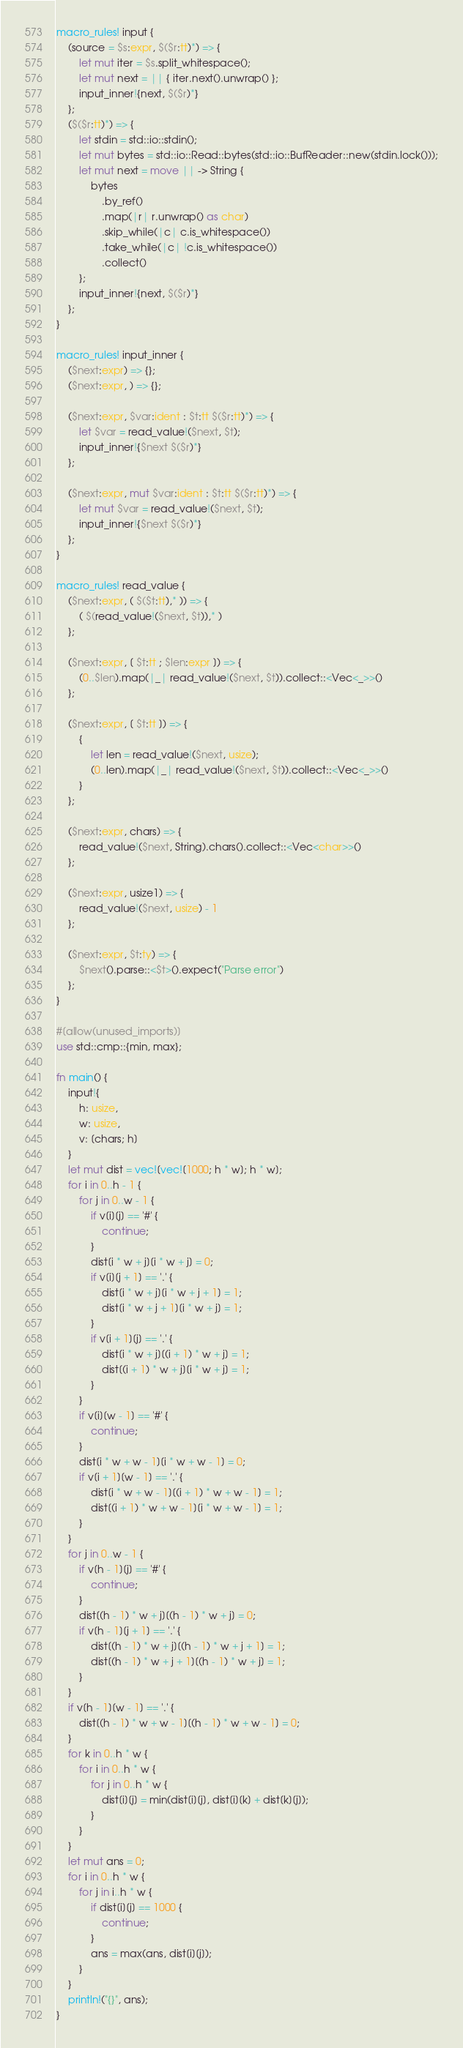Convert code to text. <code><loc_0><loc_0><loc_500><loc_500><_Rust_>macro_rules! input {
    (source = $s:expr, $($r:tt)*) => {
        let mut iter = $s.split_whitespace();
        let mut next = || { iter.next().unwrap() };
        input_inner!{next, $($r)*}
    };
    ($($r:tt)*) => {
        let stdin = std::io::stdin();
        let mut bytes = std::io::Read::bytes(std::io::BufReader::new(stdin.lock()));
        let mut next = move || -> String {
            bytes
                .by_ref()
                .map(|r| r.unwrap() as char)
                .skip_while(|c| c.is_whitespace())
                .take_while(|c| !c.is_whitespace())
                .collect()
        };
        input_inner!{next, $($r)*}
    };
}

macro_rules! input_inner {
    ($next:expr) => {};
    ($next:expr, ) => {};

    ($next:expr, $var:ident : $t:tt $($r:tt)*) => {
        let $var = read_value!($next, $t);
        input_inner!{$next $($r)*}
    };

    ($next:expr, mut $var:ident : $t:tt $($r:tt)*) => {
        let mut $var = read_value!($next, $t);
        input_inner!{$next $($r)*}
    };
}

macro_rules! read_value {
    ($next:expr, ( $($t:tt),* )) => {
        ( $(read_value!($next, $t)),* )
    };

    ($next:expr, [ $t:tt ; $len:expr ]) => {
        (0..$len).map(|_| read_value!($next, $t)).collect::<Vec<_>>()
    };

    ($next:expr, [ $t:tt ]) => {
        {
            let len = read_value!($next, usize);
            (0..len).map(|_| read_value!($next, $t)).collect::<Vec<_>>()
        }
    };

    ($next:expr, chars) => {
        read_value!($next, String).chars().collect::<Vec<char>>()
    };

    ($next:expr, usize1) => {
        read_value!($next, usize) - 1
    };

    ($next:expr, $t:ty) => {
        $next().parse::<$t>().expect("Parse error")
    };
}

#[allow(unused_imports)]
use std::cmp::{min, max};

fn main() {
    input!{
        h: usize,
        w: usize,
        v: [chars; h]
    }
    let mut dist = vec![vec![1000; h * w]; h * w];
    for i in 0..h - 1 {
        for j in 0..w - 1 {
            if v[i][j] == '#' {
                continue;
            }
            dist[i * w + j][i * w + j] = 0;
            if v[i][j + 1] == '.' {
                dist[i * w + j][i * w + j + 1] = 1;
                dist[i * w + j + 1][i * w + j] = 1;
            }
            if v[i + 1][j] == '.' {
                dist[i * w + j][(i + 1) * w + j] = 1;
                dist[(i + 1) * w + j][i * w + j] = 1;
            }
        }
        if v[i][w - 1] == '#' {
            continue;
        }
        dist[i * w + w - 1][i * w + w - 1] = 0;
        if v[i + 1][w - 1] == '.' {
            dist[i * w + w - 1][(i + 1) * w + w - 1] = 1;
            dist[(i + 1) * w + w - 1][i * w + w - 1] = 1;
        }
    }
    for j in 0..w - 1 {
        if v[h - 1][j] == '#' {
            continue;
        }
        dist[(h - 1) * w + j][(h - 1) * w + j] = 0;
        if v[h - 1][j + 1] == '.' {
            dist[(h - 1) * w + j][(h - 1) * w + j + 1] = 1;
            dist[(h - 1) * w + j + 1][(h - 1) * w + j] = 1;
        }
    }
    if v[h - 1][w - 1] == '.' {
        dist[(h - 1) * w + w - 1][(h - 1) * w + w - 1] = 0;
    }
    for k in 0..h * w {
        for i in 0..h * w {
            for j in 0..h * w {
                dist[i][j] = min(dist[i][j], dist[i][k] + dist[k][j]);
            }
        }
    }
    let mut ans = 0;
    for i in 0..h * w {
        for j in i..h * w {
            if dist[i][j] == 1000 {
                continue;
            }
            ans = max(ans, dist[i][j]);
        }
    }
    println!("{}", ans);
}
</code> 